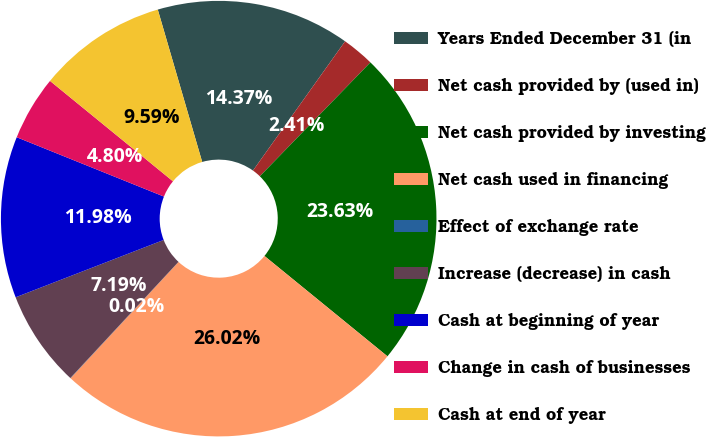Convert chart. <chart><loc_0><loc_0><loc_500><loc_500><pie_chart><fcel>Years Ended December 31 (in<fcel>Net cash provided by (used in)<fcel>Net cash provided by investing<fcel>Net cash used in financing<fcel>Effect of exchange rate<fcel>Increase (decrease) in cash<fcel>Cash at beginning of year<fcel>Change in cash of businesses<fcel>Cash at end of year<nl><fcel>14.37%<fcel>2.41%<fcel>23.63%<fcel>26.02%<fcel>0.02%<fcel>7.19%<fcel>11.98%<fcel>4.8%<fcel>9.59%<nl></chart> 